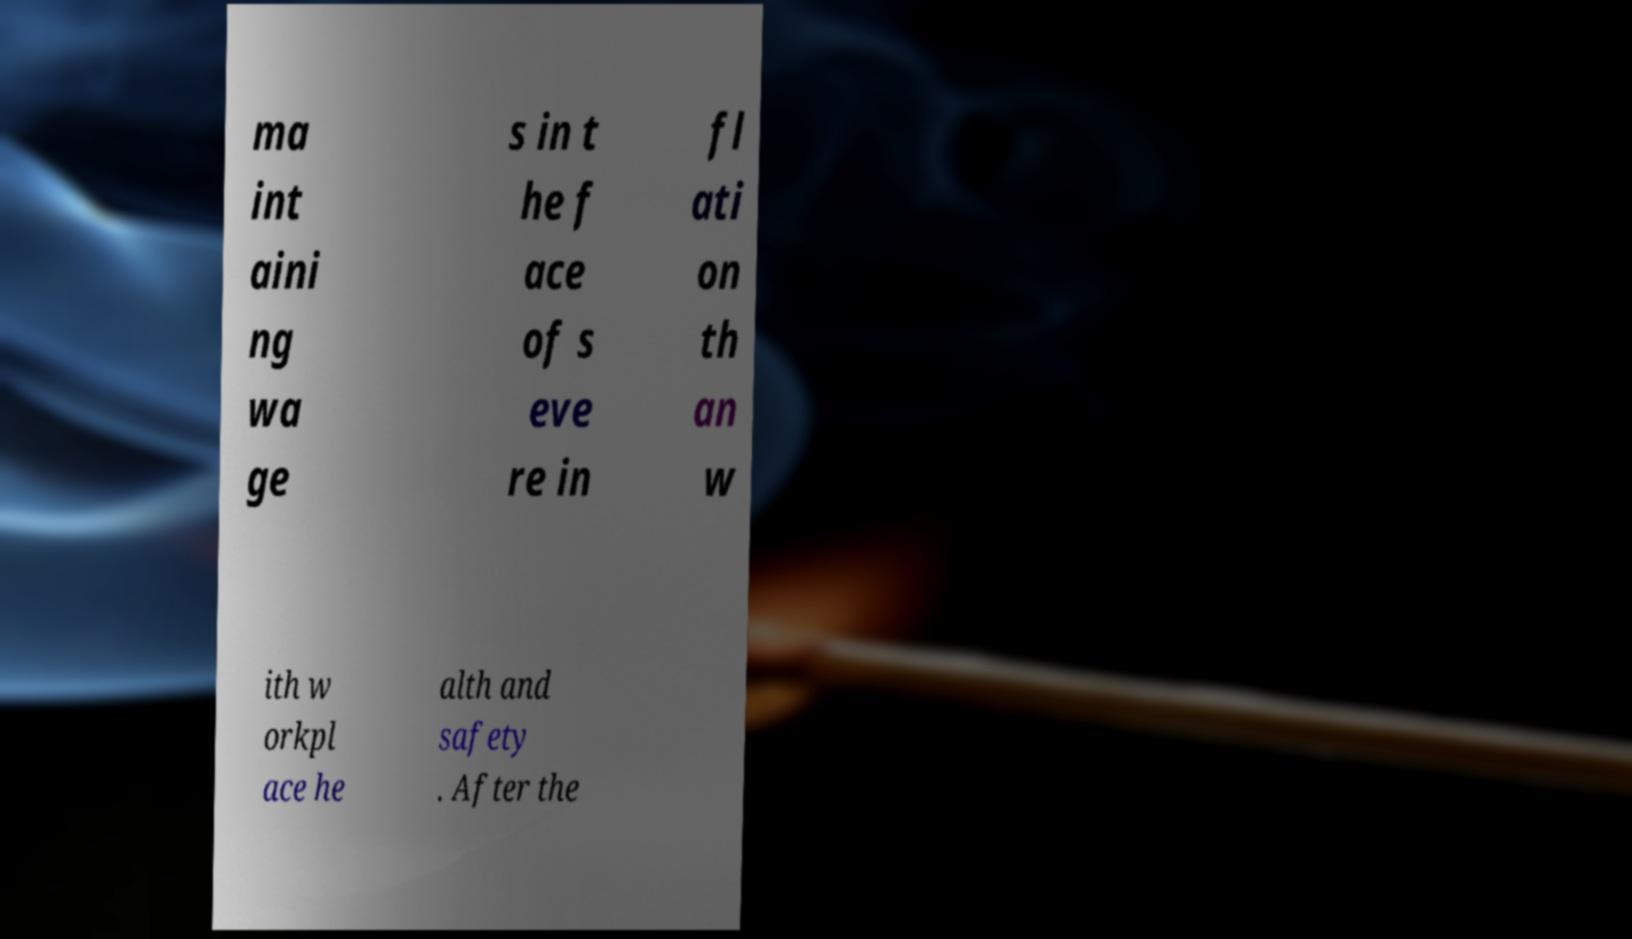What messages or text are displayed in this image? I need them in a readable, typed format. ma int aini ng wa ge s in t he f ace of s eve re in fl ati on th an w ith w orkpl ace he alth and safety . After the 